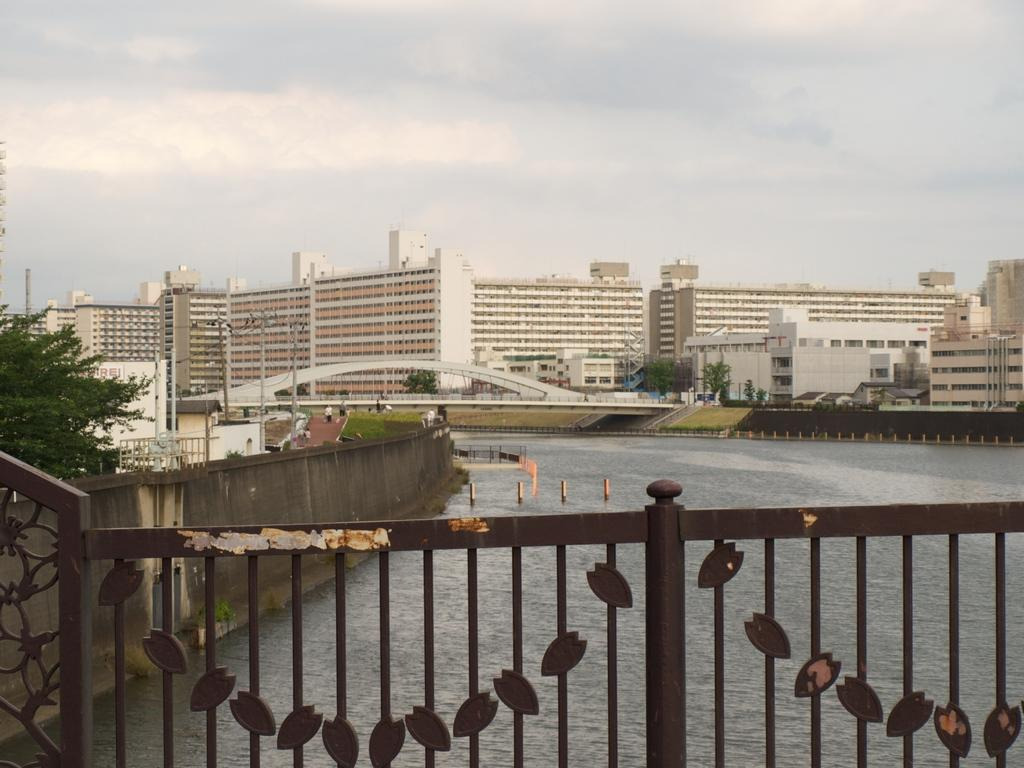What type of barrier can be seen in the image? There is a fence in the image. What natural element is visible in the image? There is water visible in the image. What type of vegetation is present in the image? There are trees in the image. What type of man-made structures are visible in the image? There are buildings in the image. What vertical structures can be seen in the image? There are poles in the image. What can be seen in the background of the image? The sky with clouds is visible in the background of the image. What type of juice is being served in the image? There is no juice present in the image. What type of straw is being used to drink the juice in the image? There is no juice or straw present in the image. 